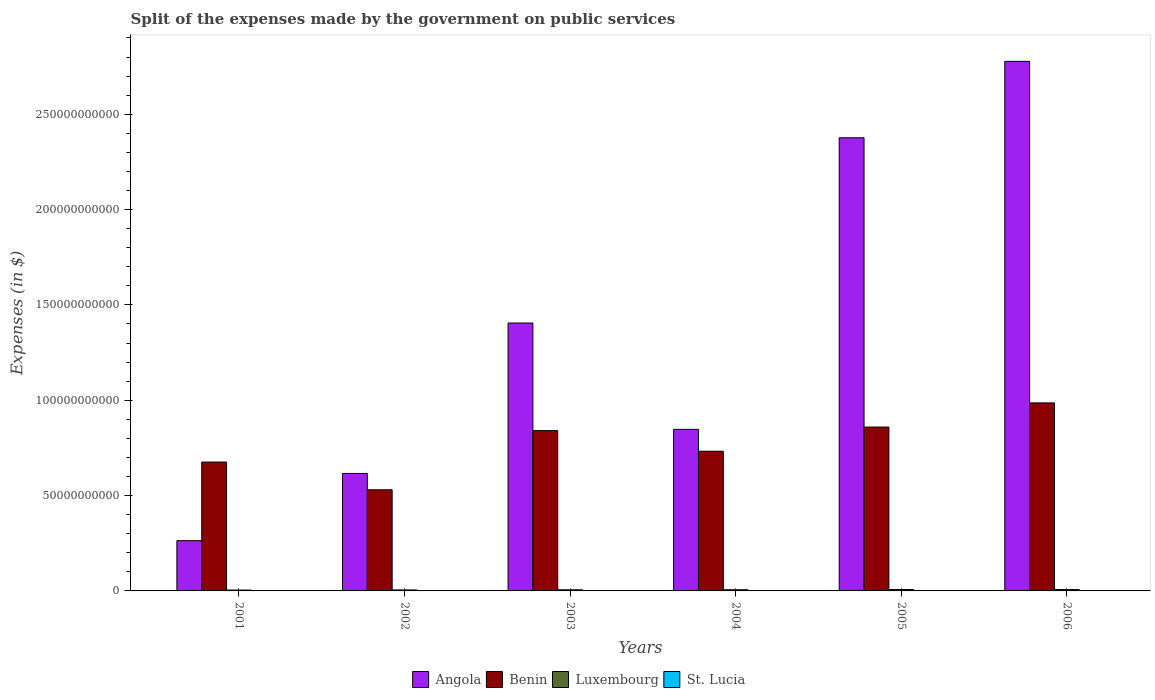How many groups of bars are there?
Your response must be concise. 6. Are the number of bars per tick equal to the number of legend labels?
Make the answer very short. Yes. What is the expenses made by the government on public services in Angola in 2001?
Offer a very short reply. 2.64e+1. Across all years, what is the maximum expenses made by the government on public services in Luxembourg?
Your response must be concise. 7.15e+08. Across all years, what is the minimum expenses made by the government on public services in Luxembourg?
Offer a very short reply. 4.57e+08. What is the total expenses made by the government on public services in Luxembourg in the graph?
Give a very brief answer. 3.60e+09. What is the difference between the expenses made by the government on public services in Luxembourg in 2005 and that in 2006?
Your response must be concise. 1.89e+07. What is the difference between the expenses made by the government on public services in St. Lucia in 2002 and the expenses made by the government on public services in Benin in 2004?
Give a very brief answer. -7.32e+1. What is the average expenses made by the government on public services in St. Lucia per year?
Keep it short and to the point. 8.68e+07. In the year 2004, what is the difference between the expenses made by the government on public services in Angola and expenses made by the government on public services in Benin?
Provide a succinct answer. 1.15e+1. In how many years, is the expenses made by the government on public services in Luxembourg greater than 270000000000 $?
Offer a terse response. 0. What is the ratio of the expenses made by the government on public services in Benin in 2002 to that in 2005?
Give a very brief answer. 0.62. Is the expenses made by the government on public services in St. Lucia in 2004 less than that in 2006?
Keep it short and to the point. Yes. What is the difference between the highest and the second highest expenses made by the government on public services in Benin?
Your response must be concise. 1.27e+1. What is the difference between the highest and the lowest expenses made by the government on public services in St. Lucia?
Your answer should be very brief. 3.96e+07. In how many years, is the expenses made by the government on public services in Luxembourg greater than the average expenses made by the government on public services in Luxembourg taken over all years?
Offer a very short reply. 3. Is the sum of the expenses made by the government on public services in Angola in 2001 and 2005 greater than the maximum expenses made by the government on public services in Benin across all years?
Provide a succinct answer. Yes. Is it the case that in every year, the sum of the expenses made by the government on public services in St. Lucia and expenses made by the government on public services in Luxembourg is greater than the sum of expenses made by the government on public services in Benin and expenses made by the government on public services in Angola?
Provide a succinct answer. No. What does the 3rd bar from the left in 2006 represents?
Provide a short and direct response. Luxembourg. What does the 2nd bar from the right in 2001 represents?
Provide a short and direct response. Luxembourg. How many bars are there?
Offer a very short reply. 24. How many years are there in the graph?
Give a very brief answer. 6. What is the difference between two consecutive major ticks on the Y-axis?
Your answer should be very brief. 5.00e+1. Does the graph contain grids?
Your response must be concise. No. Where does the legend appear in the graph?
Provide a short and direct response. Bottom center. How many legend labels are there?
Offer a very short reply. 4. What is the title of the graph?
Offer a very short reply. Split of the expenses made by the government on public services. What is the label or title of the X-axis?
Your response must be concise. Years. What is the label or title of the Y-axis?
Offer a very short reply. Expenses (in $). What is the Expenses (in $) of Angola in 2001?
Offer a terse response. 2.64e+1. What is the Expenses (in $) of Benin in 2001?
Your answer should be very brief. 6.76e+1. What is the Expenses (in $) of Luxembourg in 2001?
Your answer should be very brief. 4.57e+08. What is the Expenses (in $) of St. Lucia in 2001?
Your answer should be very brief. 7.57e+07. What is the Expenses (in $) of Angola in 2002?
Your answer should be compact. 6.16e+1. What is the Expenses (in $) of Benin in 2002?
Keep it short and to the point. 5.30e+1. What is the Expenses (in $) of Luxembourg in 2002?
Make the answer very short. 5.17e+08. What is the Expenses (in $) of St. Lucia in 2002?
Your answer should be very brief. 6.47e+07. What is the Expenses (in $) in Angola in 2003?
Ensure brevity in your answer.  1.40e+11. What is the Expenses (in $) in Benin in 2003?
Your response must be concise. 8.41e+1. What is the Expenses (in $) of Luxembourg in 2003?
Your response must be concise. 5.89e+08. What is the Expenses (in $) in St. Lucia in 2003?
Offer a terse response. 8.95e+07. What is the Expenses (in $) in Angola in 2004?
Your response must be concise. 8.47e+1. What is the Expenses (in $) of Benin in 2004?
Your answer should be compact. 7.33e+1. What is the Expenses (in $) of Luxembourg in 2004?
Your answer should be very brief. 6.20e+08. What is the Expenses (in $) of St. Lucia in 2004?
Ensure brevity in your answer.  9.55e+07. What is the Expenses (in $) of Angola in 2005?
Your answer should be very brief. 2.38e+11. What is the Expenses (in $) in Benin in 2005?
Give a very brief answer. 8.59e+1. What is the Expenses (in $) in Luxembourg in 2005?
Your answer should be very brief. 7.15e+08. What is the Expenses (in $) in St. Lucia in 2005?
Ensure brevity in your answer.  9.10e+07. What is the Expenses (in $) in Angola in 2006?
Provide a succinct answer. 2.78e+11. What is the Expenses (in $) in Benin in 2006?
Your answer should be compact. 9.86e+1. What is the Expenses (in $) of Luxembourg in 2006?
Your answer should be very brief. 6.96e+08. What is the Expenses (in $) in St. Lucia in 2006?
Give a very brief answer. 1.04e+08. Across all years, what is the maximum Expenses (in $) in Angola?
Provide a succinct answer. 2.78e+11. Across all years, what is the maximum Expenses (in $) in Benin?
Make the answer very short. 9.86e+1. Across all years, what is the maximum Expenses (in $) of Luxembourg?
Offer a terse response. 7.15e+08. Across all years, what is the maximum Expenses (in $) in St. Lucia?
Offer a very short reply. 1.04e+08. Across all years, what is the minimum Expenses (in $) of Angola?
Offer a terse response. 2.64e+1. Across all years, what is the minimum Expenses (in $) in Benin?
Keep it short and to the point. 5.30e+1. Across all years, what is the minimum Expenses (in $) of Luxembourg?
Provide a succinct answer. 4.57e+08. Across all years, what is the minimum Expenses (in $) of St. Lucia?
Give a very brief answer. 6.47e+07. What is the total Expenses (in $) of Angola in the graph?
Make the answer very short. 8.29e+11. What is the total Expenses (in $) in Benin in the graph?
Keep it short and to the point. 4.63e+11. What is the total Expenses (in $) in Luxembourg in the graph?
Provide a short and direct response. 3.60e+09. What is the total Expenses (in $) of St. Lucia in the graph?
Give a very brief answer. 5.21e+08. What is the difference between the Expenses (in $) of Angola in 2001 and that in 2002?
Provide a short and direct response. -3.53e+1. What is the difference between the Expenses (in $) in Benin in 2001 and that in 2002?
Your answer should be very brief. 1.45e+1. What is the difference between the Expenses (in $) of Luxembourg in 2001 and that in 2002?
Provide a succinct answer. -6.01e+07. What is the difference between the Expenses (in $) of St. Lucia in 2001 and that in 2002?
Offer a very short reply. 1.10e+07. What is the difference between the Expenses (in $) in Angola in 2001 and that in 2003?
Your answer should be very brief. -1.14e+11. What is the difference between the Expenses (in $) of Benin in 2001 and that in 2003?
Your response must be concise. -1.65e+1. What is the difference between the Expenses (in $) in Luxembourg in 2001 and that in 2003?
Offer a very short reply. -1.31e+08. What is the difference between the Expenses (in $) in St. Lucia in 2001 and that in 2003?
Keep it short and to the point. -1.38e+07. What is the difference between the Expenses (in $) in Angola in 2001 and that in 2004?
Keep it short and to the point. -5.84e+1. What is the difference between the Expenses (in $) in Benin in 2001 and that in 2004?
Offer a very short reply. -5.68e+09. What is the difference between the Expenses (in $) of Luxembourg in 2001 and that in 2004?
Make the answer very short. -1.62e+08. What is the difference between the Expenses (in $) in St. Lucia in 2001 and that in 2004?
Give a very brief answer. -1.98e+07. What is the difference between the Expenses (in $) of Angola in 2001 and that in 2005?
Keep it short and to the point. -2.11e+11. What is the difference between the Expenses (in $) of Benin in 2001 and that in 2005?
Ensure brevity in your answer.  -1.84e+1. What is the difference between the Expenses (in $) in Luxembourg in 2001 and that in 2005?
Your answer should be very brief. -2.58e+08. What is the difference between the Expenses (in $) of St. Lucia in 2001 and that in 2005?
Your answer should be very brief. -1.53e+07. What is the difference between the Expenses (in $) of Angola in 2001 and that in 2006?
Provide a short and direct response. -2.51e+11. What is the difference between the Expenses (in $) in Benin in 2001 and that in 2006?
Your response must be concise. -3.10e+1. What is the difference between the Expenses (in $) in Luxembourg in 2001 and that in 2006?
Keep it short and to the point. -2.39e+08. What is the difference between the Expenses (in $) of St. Lucia in 2001 and that in 2006?
Make the answer very short. -2.86e+07. What is the difference between the Expenses (in $) of Angola in 2002 and that in 2003?
Make the answer very short. -7.89e+1. What is the difference between the Expenses (in $) in Benin in 2002 and that in 2003?
Your response must be concise. -3.10e+1. What is the difference between the Expenses (in $) in Luxembourg in 2002 and that in 2003?
Offer a very short reply. -7.10e+07. What is the difference between the Expenses (in $) in St. Lucia in 2002 and that in 2003?
Your answer should be very brief. -2.48e+07. What is the difference between the Expenses (in $) of Angola in 2002 and that in 2004?
Offer a very short reply. -2.31e+1. What is the difference between the Expenses (in $) of Benin in 2002 and that in 2004?
Your answer should be compact. -2.02e+1. What is the difference between the Expenses (in $) of Luxembourg in 2002 and that in 2004?
Your response must be concise. -1.02e+08. What is the difference between the Expenses (in $) in St. Lucia in 2002 and that in 2004?
Provide a short and direct response. -3.08e+07. What is the difference between the Expenses (in $) of Angola in 2002 and that in 2005?
Provide a succinct answer. -1.76e+11. What is the difference between the Expenses (in $) in Benin in 2002 and that in 2005?
Offer a terse response. -3.29e+1. What is the difference between the Expenses (in $) of Luxembourg in 2002 and that in 2005?
Give a very brief answer. -1.98e+08. What is the difference between the Expenses (in $) of St. Lucia in 2002 and that in 2005?
Make the answer very short. -2.63e+07. What is the difference between the Expenses (in $) of Angola in 2002 and that in 2006?
Provide a succinct answer. -2.16e+11. What is the difference between the Expenses (in $) in Benin in 2002 and that in 2006?
Offer a terse response. -4.56e+1. What is the difference between the Expenses (in $) of Luxembourg in 2002 and that in 2006?
Your answer should be very brief. -1.79e+08. What is the difference between the Expenses (in $) in St. Lucia in 2002 and that in 2006?
Provide a succinct answer. -3.96e+07. What is the difference between the Expenses (in $) in Angola in 2003 and that in 2004?
Ensure brevity in your answer.  5.58e+1. What is the difference between the Expenses (in $) of Benin in 2003 and that in 2004?
Offer a terse response. 1.08e+1. What is the difference between the Expenses (in $) in Luxembourg in 2003 and that in 2004?
Offer a very short reply. -3.14e+07. What is the difference between the Expenses (in $) of St. Lucia in 2003 and that in 2004?
Your response must be concise. -6.00e+06. What is the difference between the Expenses (in $) of Angola in 2003 and that in 2005?
Your response must be concise. -9.71e+1. What is the difference between the Expenses (in $) of Benin in 2003 and that in 2005?
Your answer should be very brief. -1.86e+09. What is the difference between the Expenses (in $) in Luxembourg in 2003 and that in 2005?
Provide a succinct answer. -1.27e+08. What is the difference between the Expenses (in $) in St. Lucia in 2003 and that in 2005?
Make the answer very short. -1.50e+06. What is the difference between the Expenses (in $) of Angola in 2003 and that in 2006?
Give a very brief answer. -1.37e+11. What is the difference between the Expenses (in $) of Benin in 2003 and that in 2006?
Make the answer very short. -1.45e+1. What is the difference between the Expenses (in $) of Luxembourg in 2003 and that in 2006?
Your response must be concise. -1.08e+08. What is the difference between the Expenses (in $) in St. Lucia in 2003 and that in 2006?
Your response must be concise. -1.48e+07. What is the difference between the Expenses (in $) of Angola in 2004 and that in 2005?
Make the answer very short. -1.53e+11. What is the difference between the Expenses (in $) in Benin in 2004 and that in 2005?
Your response must be concise. -1.27e+1. What is the difference between the Expenses (in $) in Luxembourg in 2004 and that in 2005?
Provide a short and direct response. -9.55e+07. What is the difference between the Expenses (in $) of St. Lucia in 2004 and that in 2005?
Your answer should be very brief. 4.50e+06. What is the difference between the Expenses (in $) in Angola in 2004 and that in 2006?
Offer a terse response. -1.93e+11. What is the difference between the Expenses (in $) of Benin in 2004 and that in 2006?
Ensure brevity in your answer.  -2.53e+1. What is the difference between the Expenses (in $) in Luxembourg in 2004 and that in 2006?
Give a very brief answer. -7.66e+07. What is the difference between the Expenses (in $) in St. Lucia in 2004 and that in 2006?
Offer a terse response. -8.80e+06. What is the difference between the Expenses (in $) of Angola in 2005 and that in 2006?
Provide a succinct answer. -4.01e+1. What is the difference between the Expenses (in $) of Benin in 2005 and that in 2006?
Ensure brevity in your answer.  -1.27e+1. What is the difference between the Expenses (in $) in Luxembourg in 2005 and that in 2006?
Ensure brevity in your answer.  1.89e+07. What is the difference between the Expenses (in $) of St. Lucia in 2005 and that in 2006?
Offer a terse response. -1.33e+07. What is the difference between the Expenses (in $) of Angola in 2001 and the Expenses (in $) of Benin in 2002?
Keep it short and to the point. -2.67e+1. What is the difference between the Expenses (in $) in Angola in 2001 and the Expenses (in $) in Luxembourg in 2002?
Offer a very short reply. 2.58e+1. What is the difference between the Expenses (in $) in Angola in 2001 and the Expenses (in $) in St. Lucia in 2002?
Make the answer very short. 2.63e+1. What is the difference between the Expenses (in $) of Benin in 2001 and the Expenses (in $) of Luxembourg in 2002?
Offer a terse response. 6.71e+1. What is the difference between the Expenses (in $) of Benin in 2001 and the Expenses (in $) of St. Lucia in 2002?
Provide a short and direct response. 6.75e+1. What is the difference between the Expenses (in $) of Luxembourg in 2001 and the Expenses (in $) of St. Lucia in 2002?
Provide a short and direct response. 3.93e+08. What is the difference between the Expenses (in $) of Angola in 2001 and the Expenses (in $) of Benin in 2003?
Your answer should be compact. -5.77e+1. What is the difference between the Expenses (in $) of Angola in 2001 and the Expenses (in $) of Luxembourg in 2003?
Make the answer very short. 2.58e+1. What is the difference between the Expenses (in $) in Angola in 2001 and the Expenses (in $) in St. Lucia in 2003?
Your answer should be compact. 2.63e+1. What is the difference between the Expenses (in $) in Benin in 2001 and the Expenses (in $) in Luxembourg in 2003?
Your response must be concise. 6.70e+1. What is the difference between the Expenses (in $) in Benin in 2001 and the Expenses (in $) in St. Lucia in 2003?
Offer a very short reply. 6.75e+1. What is the difference between the Expenses (in $) in Luxembourg in 2001 and the Expenses (in $) in St. Lucia in 2003?
Your response must be concise. 3.68e+08. What is the difference between the Expenses (in $) in Angola in 2001 and the Expenses (in $) in Benin in 2004?
Your response must be concise. -4.69e+1. What is the difference between the Expenses (in $) in Angola in 2001 and the Expenses (in $) in Luxembourg in 2004?
Your response must be concise. 2.57e+1. What is the difference between the Expenses (in $) in Angola in 2001 and the Expenses (in $) in St. Lucia in 2004?
Your response must be concise. 2.63e+1. What is the difference between the Expenses (in $) in Benin in 2001 and the Expenses (in $) in Luxembourg in 2004?
Provide a succinct answer. 6.70e+1. What is the difference between the Expenses (in $) in Benin in 2001 and the Expenses (in $) in St. Lucia in 2004?
Keep it short and to the point. 6.75e+1. What is the difference between the Expenses (in $) in Luxembourg in 2001 and the Expenses (in $) in St. Lucia in 2004?
Provide a short and direct response. 3.62e+08. What is the difference between the Expenses (in $) in Angola in 2001 and the Expenses (in $) in Benin in 2005?
Provide a short and direct response. -5.96e+1. What is the difference between the Expenses (in $) of Angola in 2001 and the Expenses (in $) of Luxembourg in 2005?
Your answer should be very brief. 2.56e+1. What is the difference between the Expenses (in $) of Angola in 2001 and the Expenses (in $) of St. Lucia in 2005?
Provide a succinct answer. 2.63e+1. What is the difference between the Expenses (in $) of Benin in 2001 and the Expenses (in $) of Luxembourg in 2005?
Your response must be concise. 6.69e+1. What is the difference between the Expenses (in $) in Benin in 2001 and the Expenses (in $) in St. Lucia in 2005?
Keep it short and to the point. 6.75e+1. What is the difference between the Expenses (in $) in Luxembourg in 2001 and the Expenses (in $) in St. Lucia in 2005?
Give a very brief answer. 3.66e+08. What is the difference between the Expenses (in $) of Angola in 2001 and the Expenses (in $) of Benin in 2006?
Ensure brevity in your answer.  -7.23e+1. What is the difference between the Expenses (in $) in Angola in 2001 and the Expenses (in $) in Luxembourg in 2006?
Give a very brief answer. 2.57e+1. What is the difference between the Expenses (in $) of Angola in 2001 and the Expenses (in $) of St. Lucia in 2006?
Ensure brevity in your answer.  2.62e+1. What is the difference between the Expenses (in $) of Benin in 2001 and the Expenses (in $) of Luxembourg in 2006?
Provide a short and direct response. 6.69e+1. What is the difference between the Expenses (in $) of Benin in 2001 and the Expenses (in $) of St. Lucia in 2006?
Provide a short and direct response. 6.75e+1. What is the difference between the Expenses (in $) of Luxembourg in 2001 and the Expenses (in $) of St. Lucia in 2006?
Offer a terse response. 3.53e+08. What is the difference between the Expenses (in $) in Angola in 2002 and the Expenses (in $) in Benin in 2003?
Offer a very short reply. -2.25e+1. What is the difference between the Expenses (in $) of Angola in 2002 and the Expenses (in $) of Luxembourg in 2003?
Your answer should be compact. 6.10e+1. What is the difference between the Expenses (in $) in Angola in 2002 and the Expenses (in $) in St. Lucia in 2003?
Keep it short and to the point. 6.15e+1. What is the difference between the Expenses (in $) of Benin in 2002 and the Expenses (in $) of Luxembourg in 2003?
Give a very brief answer. 5.25e+1. What is the difference between the Expenses (in $) in Benin in 2002 and the Expenses (in $) in St. Lucia in 2003?
Offer a very short reply. 5.30e+1. What is the difference between the Expenses (in $) of Luxembourg in 2002 and the Expenses (in $) of St. Lucia in 2003?
Provide a short and direct response. 4.28e+08. What is the difference between the Expenses (in $) in Angola in 2002 and the Expenses (in $) in Benin in 2004?
Make the answer very short. -1.17e+1. What is the difference between the Expenses (in $) of Angola in 2002 and the Expenses (in $) of Luxembourg in 2004?
Offer a very short reply. 6.10e+1. What is the difference between the Expenses (in $) in Angola in 2002 and the Expenses (in $) in St. Lucia in 2004?
Your response must be concise. 6.15e+1. What is the difference between the Expenses (in $) of Benin in 2002 and the Expenses (in $) of Luxembourg in 2004?
Your response must be concise. 5.24e+1. What is the difference between the Expenses (in $) of Benin in 2002 and the Expenses (in $) of St. Lucia in 2004?
Provide a short and direct response. 5.30e+1. What is the difference between the Expenses (in $) of Luxembourg in 2002 and the Expenses (in $) of St. Lucia in 2004?
Offer a very short reply. 4.22e+08. What is the difference between the Expenses (in $) of Angola in 2002 and the Expenses (in $) of Benin in 2005?
Provide a short and direct response. -2.43e+1. What is the difference between the Expenses (in $) of Angola in 2002 and the Expenses (in $) of Luxembourg in 2005?
Your response must be concise. 6.09e+1. What is the difference between the Expenses (in $) in Angola in 2002 and the Expenses (in $) in St. Lucia in 2005?
Offer a terse response. 6.15e+1. What is the difference between the Expenses (in $) of Benin in 2002 and the Expenses (in $) of Luxembourg in 2005?
Give a very brief answer. 5.23e+1. What is the difference between the Expenses (in $) in Benin in 2002 and the Expenses (in $) in St. Lucia in 2005?
Offer a terse response. 5.30e+1. What is the difference between the Expenses (in $) of Luxembourg in 2002 and the Expenses (in $) of St. Lucia in 2005?
Keep it short and to the point. 4.26e+08. What is the difference between the Expenses (in $) of Angola in 2002 and the Expenses (in $) of Benin in 2006?
Provide a short and direct response. -3.70e+1. What is the difference between the Expenses (in $) in Angola in 2002 and the Expenses (in $) in Luxembourg in 2006?
Keep it short and to the point. 6.09e+1. What is the difference between the Expenses (in $) in Angola in 2002 and the Expenses (in $) in St. Lucia in 2006?
Ensure brevity in your answer.  6.15e+1. What is the difference between the Expenses (in $) of Benin in 2002 and the Expenses (in $) of Luxembourg in 2006?
Ensure brevity in your answer.  5.24e+1. What is the difference between the Expenses (in $) of Benin in 2002 and the Expenses (in $) of St. Lucia in 2006?
Provide a succinct answer. 5.29e+1. What is the difference between the Expenses (in $) in Luxembourg in 2002 and the Expenses (in $) in St. Lucia in 2006?
Your answer should be compact. 4.13e+08. What is the difference between the Expenses (in $) in Angola in 2003 and the Expenses (in $) in Benin in 2004?
Provide a succinct answer. 6.72e+1. What is the difference between the Expenses (in $) in Angola in 2003 and the Expenses (in $) in Luxembourg in 2004?
Provide a short and direct response. 1.40e+11. What is the difference between the Expenses (in $) of Angola in 2003 and the Expenses (in $) of St. Lucia in 2004?
Your answer should be compact. 1.40e+11. What is the difference between the Expenses (in $) of Benin in 2003 and the Expenses (in $) of Luxembourg in 2004?
Keep it short and to the point. 8.35e+1. What is the difference between the Expenses (in $) of Benin in 2003 and the Expenses (in $) of St. Lucia in 2004?
Your answer should be very brief. 8.40e+1. What is the difference between the Expenses (in $) in Luxembourg in 2003 and the Expenses (in $) in St. Lucia in 2004?
Your answer should be very brief. 4.93e+08. What is the difference between the Expenses (in $) in Angola in 2003 and the Expenses (in $) in Benin in 2005?
Provide a short and direct response. 5.46e+1. What is the difference between the Expenses (in $) in Angola in 2003 and the Expenses (in $) in Luxembourg in 2005?
Keep it short and to the point. 1.40e+11. What is the difference between the Expenses (in $) in Angola in 2003 and the Expenses (in $) in St. Lucia in 2005?
Give a very brief answer. 1.40e+11. What is the difference between the Expenses (in $) of Benin in 2003 and the Expenses (in $) of Luxembourg in 2005?
Give a very brief answer. 8.34e+1. What is the difference between the Expenses (in $) in Benin in 2003 and the Expenses (in $) in St. Lucia in 2005?
Your answer should be compact. 8.40e+1. What is the difference between the Expenses (in $) of Luxembourg in 2003 and the Expenses (in $) of St. Lucia in 2005?
Ensure brevity in your answer.  4.98e+08. What is the difference between the Expenses (in $) of Angola in 2003 and the Expenses (in $) of Benin in 2006?
Provide a short and direct response. 4.19e+1. What is the difference between the Expenses (in $) of Angola in 2003 and the Expenses (in $) of Luxembourg in 2006?
Ensure brevity in your answer.  1.40e+11. What is the difference between the Expenses (in $) of Angola in 2003 and the Expenses (in $) of St. Lucia in 2006?
Make the answer very short. 1.40e+11. What is the difference between the Expenses (in $) of Benin in 2003 and the Expenses (in $) of Luxembourg in 2006?
Keep it short and to the point. 8.34e+1. What is the difference between the Expenses (in $) in Benin in 2003 and the Expenses (in $) in St. Lucia in 2006?
Offer a very short reply. 8.40e+1. What is the difference between the Expenses (in $) in Luxembourg in 2003 and the Expenses (in $) in St. Lucia in 2006?
Give a very brief answer. 4.84e+08. What is the difference between the Expenses (in $) in Angola in 2004 and the Expenses (in $) in Benin in 2005?
Your answer should be compact. -1.21e+09. What is the difference between the Expenses (in $) in Angola in 2004 and the Expenses (in $) in Luxembourg in 2005?
Your answer should be compact. 8.40e+1. What is the difference between the Expenses (in $) of Angola in 2004 and the Expenses (in $) of St. Lucia in 2005?
Your answer should be compact. 8.46e+1. What is the difference between the Expenses (in $) in Benin in 2004 and the Expenses (in $) in Luxembourg in 2005?
Your answer should be compact. 7.25e+1. What is the difference between the Expenses (in $) of Benin in 2004 and the Expenses (in $) of St. Lucia in 2005?
Provide a succinct answer. 7.32e+1. What is the difference between the Expenses (in $) in Luxembourg in 2004 and the Expenses (in $) in St. Lucia in 2005?
Make the answer very short. 5.29e+08. What is the difference between the Expenses (in $) of Angola in 2004 and the Expenses (in $) of Benin in 2006?
Your answer should be compact. -1.39e+1. What is the difference between the Expenses (in $) of Angola in 2004 and the Expenses (in $) of Luxembourg in 2006?
Provide a short and direct response. 8.40e+1. What is the difference between the Expenses (in $) of Angola in 2004 and the Expenses (in $) of St. Lucia in 2006?
Offer a very short reply. 8.46e+1. What is the difference between the Expenses (in $) of Benin in 2004 and the Expenses (in $) of Luxembourg in 2006?
Make the answer very short. 7.26e+1. What is the difference between the Expenses (in $) in Benin in 2004 and the Expenses (in $) in St. Lucia in 2006?
Offer a terse response. 7.32e+1. What is the difference between the Expenses (in $) in Luxembourg in 2004 and the Expenses (in $) in St. Lucia in 2006?
Make the answer very short. 5.16e+08. What is the difference between the Expenses (in $) of Angola in 2005 and the Expenses (in $) of Benin in 2006?
Your answer should be compact. 1.39e+11. What is the difference between the Expenses (in $) of Angola in 2005 and the Expenses (in $) of Luxembourg in 2006?
Offer a terse response. 2.37e+11. What is the difference between the Expenses (in $) in Angola in 2005 and the Expenses (in $) in St. Lucia in 2006?
Make the answer very short. 2.38e+11. What is the difference between the Expenses (in $) of Benin in 2005 and the Expenses (in $) of Luxembourg in 2006?
Provide a succinct answer. 8.52e+1. What is the difference between the Expenses (in $) of Benin in 2005 and the Expenses (in $) of St. Lucia in 2006?
Provide a short and direct response. 8.58e+1. What is the difference between the Expenses (in $) of Luxembourg in 2005 and the Expenses (in $) of St. Lucia in 2006?
Offer a terse response. 6.11e+08. What is the average Expenses (in $) of Angola per year?
Keep it short and to the point. 1.38e+11. What is the average Expenses (in $) in Benin per year?
Provide a short and direct response. 7.71e+1. What is the average Expenses (in $) in Luxembourg per year?
Provide a short and direct response. 5.99e+08. What is the average Expenses (in $) in St. Lucia per year?
Make the answer very short. 8.68e+07. In the year 2001, what is the difference between the Expenses (in $) of Angola and Expenses (in $) of Benin?
Provide a short and direct response. -4.12e+1. In the year 2001, what is the difference between the Expenses (in $) in Angola and Expenses (in $) in Luxembourg?
Ensure brevity in your answer.  2.59e+1. In the year 2001, what is the difference between the Expenses (in $) of Angola and Expenses (in $) of St. Lucia?
Your answer should be very brief. 2.63e+1. In the year 2001, what is the difference between the Expenses (in $) of Benin and Expenses (in $) of Luxembourg?
Your answer should be compact. 6.71e+1. In the year 2001, what is the difference between the Expenses (in $) of Benin and Expenses (in $) of St. Lucia?
Offer a terse response. 6.75e+1. In the year 2001, what is the difference between the Expenses (in $) of Luxembourg and Expenses (in $) of St. Lucia?
Your answer should be compact. 3.82e+08. In the year 2002, what is the difference between the Expenses (in $) of Angola and Expenses (in $) of Benin?
Your answer should be compact. 8.56e+09. In the year 2002, what is the difference between the Expenses (in $) in Angola and Expenses (in $) in Luxembourg?
Provide a succinct answer. 6.11e+1. In the year 2002, what is the difference between the Expenses (in $) of Angola and Expenses (in $) of St. Lucia?
Offer a very short reply. 6.15e+1. In the year 2002, what is the difference between the Expenses (in $) in Benin and Expenses (in $) in Luxembourg?
Offer a very short reply. 5.25e+1. In the year 2002, what is the difference between the Expenses (in $) of Benin and Expenses (in $) of St. Lucia?
Your response must be concise. 5.30e+1. In the year 2002, what is the difference between the Expenses (in $) of Luxembourg and Expenses (in $) of St. Lucia?
Ensure brevity in your answer.  4.53e+08. In the year 2003, what is the difference between the Expenses (in $) of Angola and Expenses (in $) of Benin?
Give a very brief answer. 5.64e+1. In the year 2003, what is the difference between the Expenses (in $) of Angola and Expenses (in $) of Luxembourg?
Your response must be concise. 1.40e+11. In the year 2003, what is the difference between the Expenses (in $) of Angola and Expenses (in $) of St. Lucia?
Your answer should be compact. 1.40e+11. In the year 2003, what is the difference between the Expenses (in $) of Benin and Expenses (in $) of Luxembourg?
Provide a succinct answer. 8.35e+1. In the year 2003, what is the difference between the Expenses (in $) in Benin and Expenses (in $) in St. Lucia?
Keep it short and to the point. 8.40e+1. In the year 2003, what is the difference between the Expenses (in $) in Luxembourg and Expenses (in $) in St. Lucia?
Give a very brief answer. 4.99e+08. In the year 2004, what is the difference between the Expenses (in $) of Angola and Expenses (in $) of Benin?
Make the answer very short. 1.15e+1. In the year 2004, what is the difference between the Expenses (in $) in Angola and Expenses (in $) in Luxembourg?
Make the answer very short. 8.41e+1. In the year 2004, what is the difference between the Expenses (in $) in Angola and Expenses (in $) in St. Lucia?
Offer a terse response. 8.46e+1. In the year 2004, what is the difference between the Expenses (in $) of Benin and Expenses (in $) of Luxembourg?
Make the answer very short. 7.26e+1. In the year 2004, what is the difference between the Expenses (in $) in Benin and Expenses (in $) in St. Lucia?
Give a very brief answer. 7.32e+1. In the year 2004, what is the difference between the Expenses (in $) in Luxembourg and Expenses (in $) in St. Lucia?
Offer a very short reply. 5.24e+08. In the year 2005, what is the difference between the Expenses (in $) in Angola and Expenses (in $) in Benin?
Your answer should be compact. 1.52e+11. In the year 2005, what is the difference between the Expenses (in $) in Angola and Expenses (in $) in Luxembourg?
Offer a terse response. 2.37e+11. In the year 2005, what is the difference between the Expenses (in $) of Angola and Expenses (in $) of St. Lucia?
Provide a succinct answer. 2.38e+11. In the year 2005, what is the difference between the Expenses (in $) of Benin and Expenses (in $) of Luxembourg?
Offer a very short reply. 8.52e+1. In the year 2005, what is the difference between the Expenses (in $) in Benin and Expenses (in $) in St. Lucia?
Ensure brevity in your answer.  8.58e+1. In the year 2005, what is the difference between the Expenses (in $) in Luxembourg and Expenses (in $) in St. Lucia?
Provide a succinct answer. 6.24e+08. In the year 2006, what is the difference between the Expenses (in $) in Angola and Expenses (in $) in Benin?
Offer a terse response. 1.79e+11. In the year 2006, what is the difference between the Expenses (in $) of Angola and Expenses (in $) of Luxembourg?
Your response must be concise. 2.77e+11. In the year 2006, what is the difference between the Expenses (in $) of Angola and Expenses (in $) of St. Lucia?
Offer a terse response. 2.78e+11. In the year 2006, what is the difference between the Expenses (in $) of Benin and Expenses (in $) of Luxembourg?
Give a very brief answer. 9.79e+1. In the year 2006, what is the difference between the Expenses (in $) in Benin and Expenses (in $) in St. Lucia?
Make the answer very short. 9.85e+1. In the year 2006, what is the difference between the Expenses (in $) in Luxembourg and Expenses (in $) in St. Lucia?
Your answer should be compact. 5.92e+08. What is the ratio of the Expenses (in $) in Angola in 2001 to that in 2002?
Provide a short and direct response. 0.43. What is the ratio of the Expenses (in $) in Benin in 2001 to that in 2002?
Provide a short and direct response. 1.27. What is the ratio of the Expenses (in $) in Luxembourg in 2001 to that in 2002?
Give a very brief answer. 0.88. What is the ratio of the Expenses (in $) in St. Lucia in 2001 to that in 2002?
Offer a terse response. 1.17. What is the ratio of the Expenses (in $) in Angola in 2001 to that in 2003?
Make the answer very short. 0.19. What is the ratio of the Expenses (in $) in Benin in 2001 to that in 2003?
Provide a succinct answer. 0.8. What is the ratio of the Expenses (in $) of Luxembourg in 2001 to that in 2003?
Your answer should be very brief. 0.78. What is the ratio of the Expenses (in $) of St. Lucia in 2001 to that in 2003?
Your response must be concise. 0.85. What is the ratio of the Expenses (in $) of Angola in 2001 to that in 2004?
Your answer should be compact. 0.31. What is the ratio of the Expenses (in $) of Benin in 2001 to that in 2004?
Your response must be concise. 0.92. What is the ratio of the Expenses (in $) of Luxembourg in 2001 to that in 2004?
Provide a short and direct response. 0.74. What is the ratio of the Expenses (in $) in St. Lucia in 2001 to that in 2004?
Offer a very short reply. 0.79. What is the ratio of the Expenses (in $) in Angola in 2001 to that in 2005?
Ensure brevity in your answer.  0.11. What is the ratio of the Expenses (in $) in Benin in 2001 to that in 2005?
Your answer should be very brief. 0.79. What is the ratio of the Expenses (in $) of Luxembourg in 2001 to that in 2005?
Ensure brevity in your answer.  0.64. What is the ratio of the Expenses (in $) of St. Lucia in 2001 to that in 2005?
Offer a very short reply. 0.83. What is the ratio of the Expenses (in $) of Angola in 2001 to that in 2006?
Offer a very short reply. 0.09. What is the ratio of the Expenses (in $) in Benin in 2001 to that in 2006?
Make the answer very short. 0.69. What is the ratio of the Expenses (in $) in Luxembourg in 2001 to that in 2006?
Your answer should be very brief. 0.66. What is the ratio of the Expenses (in $) of St. Lucia in 2001 to that in 2006?
Make the answer very short. 0.73. What is the ratio of the Expenses (in $) in Angola in 2002 to that in 2003?
Your response must be concise. 0.44. What is the ratio of the Expenses (in $) in Benin in 2002 to that in 2003?
Provide a short and direct response. 0.63. What is the ratio of the Expenses (in $) in Luxembourg in 2002 to that in 2003?
Your answer should be very brief. 0.88. What is the ratio of the Expenses (in $) in St. Lucia in 2002 to that in 2003?
Offer a very short reply. 0.72. What is the ratio of the Expenses (in $) of Angola in 2002 to that in 2004?
Your answer should be compact. 0.73. What is the ratio of the Expenses (in $) of Benin in 2002 to that in 2004?
Provide a succinct answer. 0.72. What is the ratio of the Expenses (in $) in Luxembourg in 2002 to that in 2004?
Keep it short and to the point. 0.83. What is the ratio of the Expenses (in $) of St. Lucia in 2002 to that in 2004?
Give a very brief answer. 0.68. What is the ratio of the Expenses (in $) of Angola in 2002 to that in 2005?
Your response must be concise. 0.26. What is the ratio of the Expenses (in $) of Benin in 2002 to that in 2005?
Provide a short and direct response. 0.62. What is the ratio of the Expenses (in $) in Luxembourg in 2002 to that in 2005?
Offer a terse response. 0.72. What is the ratio of the Expenses (in $) in St. Lucia in 2002 to that in 2005?
Ensure brevity in your answer.  0.71. What is the ratio of the Expenses (in $) of Angola in 2002 to that in 2006?
Make the answer very short. 0.22. What is the ratio of the Expenses (in $) of Benin in 2002 to that in 2006?
Provide a short and direct response. 0.54. What is the ratio of the Expenses (in $) of Luxembourg in 2002 to that in 2006?
Offer a very short reply. 0.74. What is the ratio of the Expenses (in $) in St. Lucia in 2002 to that in 2006?
Your answer should be compact. 0.62. What is the ratio of the Expenses (in $) in Angola in 2003 to that in 2004?
Your answer should be very brief. 1.66. What is the ratio of the Expenses (in $) of Benin in 2003 to that in 2004?
Keep it short and to the point. 1.15. What is the ratio of the Expenses (in $) of Luxembourg in 2003 to that in 2004?
Offer a very short reply. 0.95. What is the ratio of the Expenses (in $) of St. Lucia in 2003 to that in 2004?
Keep it short and to the point. 0.94. What is the ratio of the Expenses (in $) of Angola in 2003 to that in 2005?
Make the answer very short. 0.59. What is the ratio of the Expenses (in $) of Benin in 2003 to that in 2005?
Your response must be concise. 0.98. What is the ratio of the Expenses (in $) in Luxembourg in 2003 to that in 2005?
Give a very brief answer. 0.82. What is the ratio of the Expenses (in $) in St. Lucia in 2003 to that in 2005?
Provide a succinct answer. 0.98. What is the ratio of the Expenses (in $) of Angola in 2003 to that in 2006?
Provide a short and direct response. 0.51. What is the ratio of the Expenses (in $) of Benin in 2003 to that in 2006?
Keep it short and to the point. 0.85. What is the ratio of the Expenses (in $) in Luxembourg in 2003 to that in 2006?
Keep it short and to the point. 0.84. What is the ratio of the Expenses (in $) in St. Lucia in 2003 to that in 2006?
Offer a very short reply. 0.86. What is the ratio of the Expenses (in $) in Angola in 2004 to that in 2005?
Provide a succinct answer. 0.36. What is the ratio of the Expenses (in $) of Benin in 2004 to that in 2005?
Your response must be concise. 0.85. What is the ratio of the Expenses (in $) in Luxembourg in 2004 to that in 2005?
Provide a succinct answer. 0.87. What is the ratio of the Expenses (in $) in St. Lucia in 2004 to that in 2005?
Provide a succinct answer. 1.05. What is the ratio of the Expenses (in $) in Angola in 2004 to that in 2006?
Provide a short and direct response. 0.31. What is the ratio of the Expenses (in $) in Benin in 2004 to that in 2006?
Your answer should be compact. 0.74. What is the ratio of the Expenses (in $) of Luxembourg in 2004 to that in 2006?
Your answer should be very brief. 0.89. What is the ratio of the Expenses (in $) of St. Lucia in 2004 to that in 2006?
Give a very brief answer. 0.92. What is the ratio of the Expenses (in $) of Angola in 2005 to that in 2006?
Keep it short and to the point. 0.86. What is the ratio of the Expenses (in $) of Benin in 2005 to that in 2006?
Provide a succinct answer. 0.87. What is the ratio of the Expenses (in $) in Luxembourg in 2005 to that in 2006?
Your answer should be very brief. 1.03. What is the ratio of the Expenses (in $) of St. Lucia in 2005 to that in 2006?
Offer a terse response. 0.87. What is the difference between the highest and the second highest Expenses (in $) in Angola?
Give a very brief answer. 4.01e+1. What is the difference between the highest and the second highest Expenses (in $) of Benin?
Make the answer very short. 1.27e+1. What is the difference between the highest and the second highest Expenses (in $) in Luxembourg?
Make the answer very short. 1.89e+07. What is the difference between the highest and the second highest Expenses (in $) in St. Lucia?
Keep it short and to the point. 8.80e+06. What is the difference between the highest and the lowest Expenses (in $) in Angola?
Ensure brevity in your answer.  2.51e+11. What is the difference between the highest and the lowest Expenses (in $) of Benin?
Give a very brief answer. 4.56e+1. What is the difference between the highest and the lowest Expenses (in $) of Luxembourg?
Your response must be concise. 2.58e+08. What is the difference between the highest and the lowest Expenses (in $) in St. Lucia?
Make the answer very short. 3.96e+07. 